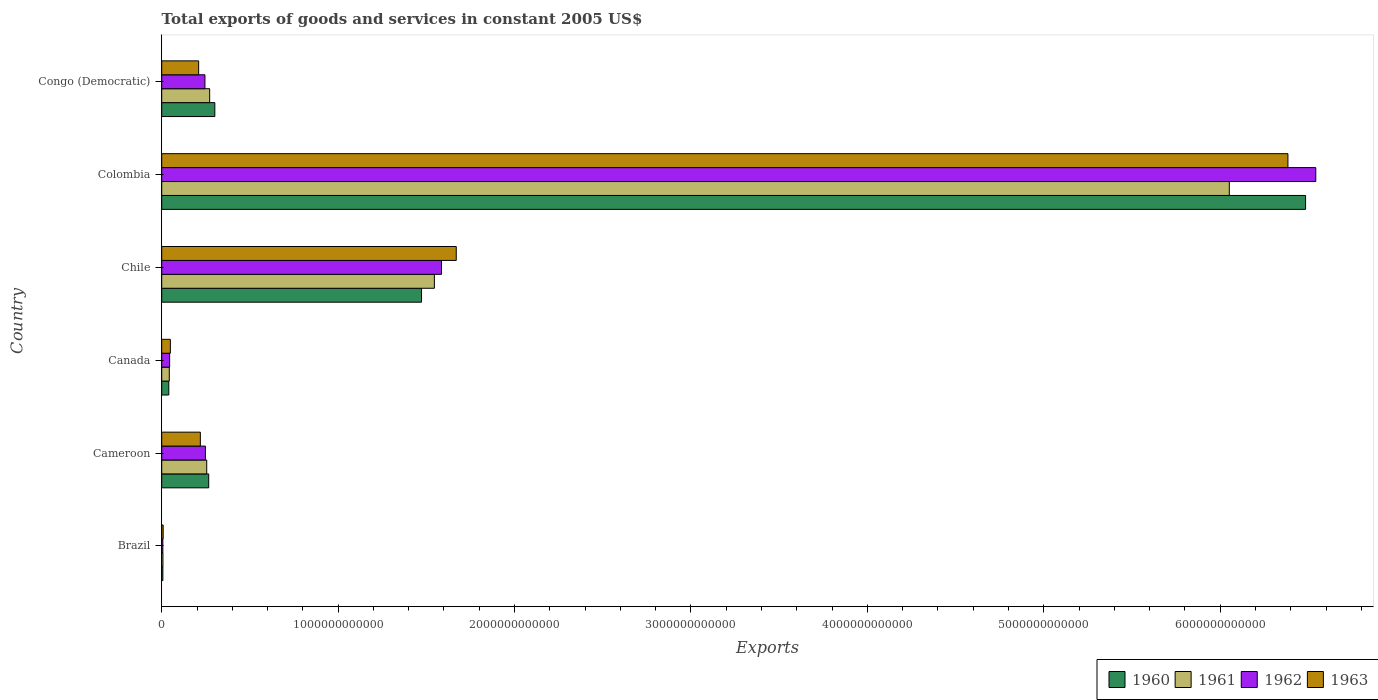How many different coloured bars are there?
Ensure brevity in your answer.  4. Are the number of bars per tick equal to the number of legend labels?
Make the answer very short. Yes. How many bars are there on the 5th tick from the top?
Offer a terse response. 4. What is the total exports of goods and services in 1962 in Congo (Democratic)?
Provide a short and direct response. 2.45e+11. Across all countries, what is the maximum total exports of goods and services in 1960?
Your response must be concise. 6.48e+12. Across all countries, what is the minimum total exports of goods and services in 1960?
Provide a short and direct response. 6.63e+09. In which country was the total exports of goods and services in 1963 maximum?
Your response must be concise. Colombia. In which country was the total exports of goods and services in 1961 minimum?
Keep it short and to the point. Brazil. What is the total total exports of goods and services in 1960 in the graph?
Your response must be concise. 8.57e+12. What is the difference between the total exports of goods and services in 1962 in Brazil and that in Colombia?
Make the answer very short. -6.54e+12. What is the difference between the total exports of goods and services in 1960 in Chile and the total exports of goods and services in 1962 in Colombia?
Offer a very short reply. -5.07e+12. What is the average total exports of goods and services in 1960 per country?
Make the answer very short. 1.43e+12. What is the difference between the total exports of goods and services in 1962 and total exports of goods and services in 1961 in Congo (Democratic)?
Offer a terse response. -2.67e+1. What is the ratio of the total exports of goods and services in 1961 in Brazil to that in Canada?
Provide a succinct answer. 0.16. Is the difference between the total exports of goods and services in 1962 in Brazil and Cameroon greater than the difference between the total exports of goods and services in 1961 in Brazil and Cameroon?
Keep it short and to the point. Yes. What is the difference between the highest and the second highest total exports of goods and services in 1962?
Your answer should be very brief. 4.96e+12. What is the difference between the highest and the lowest total exports of goods and services in 1963?
Make the answer very short. 6.38e+12. In how many countries, is the total exports of goods and services in 1961 greater than the average total exports of goods and services in 1961 taken over all countries?
Ensure brevity in your answer.  2. Is it the case that in every country, the sum of the total exports of goods and services in 1960 and total exports of goods and services in 1962 is greater than the sum of total exports of goods and services in 1961 and total exports of goods and services in 1963?
Your answer should be very brief. No. What does the 3rd bar from the bottom in Chile represents?
Make the answer very short. 1962. Is it the case that in every country, the sum of the total exports of goods and services in 1961 and total exports of goods and services in 1962 is greater than the total exports of goods and services in 1960?
Your answer should be compact. Yes. How many bars are there?
Provide a succinct answer. 24. Are all the bars in the graph horizontal?
Your answer should be very brief. Yes. What is the difference between two consecutive major ticks on the X-axis?
Make the answer very short. 1.00e+12. Are the values on the major ticks of X-axis written in scientific E-notation?
Keep it short and to the point. No. Where does the legend appear in the graph?
Give a very brief answer. Bottom right. How are the legend labels stacked?
Offer a very short reply. Horizontal. What is the title of the graph?
Offer a very short reply. Total exports of goods and services in constant 2005 US$. What is the label or title of the X-axis?
Provide a short and direct response. Exports. What is the Exports in 1960 in Brazil?
Your response must be concise. 6.63e+09. What is the Exports of 1961 in Brazil?
Offer a terse response. 6.97e+09. What is the Exports of 1962 in Brazil?
Provide a succinct answer. 6.46e+09. What is the Exports in 1963 in Brazil?
Your response must be concise. 8.26e+09. What is the Exports in 1960 in Cameroon?
Give a very brief answer. 2.66e+11. What is the Exports in 1961 in Cameroon?
Your answer should be very brief. 2.55e+11. What is the Exports in 1962 in Cameroon?
Give a very brief answer. 2.48e+11. What is the Exports in 1963 in Cameroon?
Give a very brief answer. 2.19e+11. What is the Exports in 1960 in Canada?
Ensure brevity in your answer.  4.02e+1. What is the Exports in 1961 in Canada?
Keep it short and to the point. 4.29e+1. What is the Exports in 1962 in Canada?
Your answer should be very brief. 4.49e+1. What is the Exports of 1963 in Canada?
Offer a very short reply. 4.91e+1. What is the Exports of 1960 in Chile?
Make the answer very short. 1.47e+12. What is the Exports in 1961 in Chile?
Your answer should be very brief. 1.55e+12. What is the Exports in 1962 in Chile?
Keep it short and to the point. 1.59e+12. What is the Exports of 1963 in Chile?
Your response must be concise. 1.67e+12. What is the Exports of 1960 in Colombia?
Your answer should be very brief. 6.48e+12. What is the Exports in 1961 in Colombia?
Keep it short and to the point. 6.05e+12. What is the Exports of 1962 in Colombia?
Provide a short and direct response. 6.54e+12. What is the Exports in 1963 in Colombia?
Your response must be concise. 6.38e+12. What is the Exports of 1960 in Congo (Democratic)?
Provide a succinct answer. 3.01e+11. What is the Exports of 1961 in Congo (Democratic)?
Make the answer very short. 2.72e+11. What is the Exports in 1962 in Congo (Democratic)?
Your answer should be compact. 2.45e+11. What is the Exports in 1963 in Congo (Democratic)?
Keep it short and to the point. 2.09e+11. Across all countries, what is the maximum Exports of 1960?
Keep it short and to the point. 6.48e+12. Across all countries, what is the maximum Exports in 1961?
Provide a short and direct response. 6.05e+12. Across all countries, what is the maximum Exports of 1962?
Provide a short and direct response. 6.54e+12. Across all countries, what is the maximum Exports in 1963?
Offer a very short reply. 6.38e+12. Across all countries, what is the minimum Exports of 1960?
Offer a terse response. 6.63e+09. Across all countries, what is the minimum Exports in 1961?
Offer a terse response. 6.97e+09. Across all countries, what is the minimum Exports of 1962?
Provide a short and direct response. 6.46e+09. Across all countries, what is the minimum Exports in 1963?
Provide a short and direct response. 8.26e+09. What is the total Exports in 1960 in the graph?
Provide a short and direct response. 8.57e+12. What is the total Exports of 1961 in the graph?
Provide a succinct answer. 8.17e+12. What is the total Exports in 1962 in the graph?
Give a very brief answer. 8.67e+12. What is the total Exports of 1963 in the graph?
Ensure brevity in your answer.  8.54e+12. What is the difference between the Exports in 1960 in Brazil and that in Cameroon?
Your answer should be very brief. -2.60e+11. What is the difference between the Exports of 1961 in Brazil and that in Cameroon?
Your answer should be very brief. -2.48e+11. What is the difference between the Exports of 1962 in Brazil and that in Cameroon?
Provide a succinct answer. -2.41e+11. What is the difference between the Exports in 1963 in Brazil and that in Cameroon?
Give a very brief answer. -2.11e+11. What is the difference between the Exports in 1960 in Brazil and that in Canada?
Your answer should be very brief. -3.36e+1. What is the difference between the Exports of 1961 in Brazil and that in Canada?
Provide a short and direct response. -3.60e+1. What is the difference between the Exports of 1962 in Brazil and that in Canada?
Keep it short and to the point. -3.85e+1. What is the difference between the Exports in 1963 in Brazil and that in Canada?
Make the answer very short. -4.08e+1. What is the difference between the Exports in 1960 in Brazil and that in Chile?
Your response must be concise. -1.47e+12. What is the difference between the Exports of 1961 in Brazil and that in Chile?
Provide a succinct answer. -1.54e+12. What is the difference between the Exports of 1962 in Brazil and that in Chile?
Your response must be concise. -1.58e+12. What is the difference between the Exports of 1963 in Brazil and that in Chile?
Make the answer very short. -1.66e+12. What is the difference between the Exports of 1960 in Brazil and that in Colombia?
Your answer should be compact. -6.48e+12. What is the difference between the Exports in 1961 in Brazil and that in Colombia?
Offer a terse response. -6.04e+12. What is the difference between the Exports in 1962 in Brazil and that in Colombia?
Provide a succinct answer. -6.54e+12. What is the difference between the Exports of 1963 in Brazil and that in Colombia?
Your answer should be compact. -6.38e+12. What is the difference between the Exports of 1960 in Brazil and that in Congo (Democratic)?
Provide a short and direct response. -2.94e+11. What is the difference between the Exports of 1961 in Brazil and that in Congo (Democratic)?
Provide a short and direct response. -2.65e+11. What is the difference between the Exports in 1962 in Brazil and that in Congo (Democratic)?
Make the answer very short. -2.39e+11. What is the difference between the Exports of 1963 in Brazil and that in Congo (Democratic)?
Offer a terse response. -2.01e+11. What is the difference between the Exports in 1960 in Cameroon and that in Canada?
Keep it short and to the point. 2.26e+11. What is the difference between the Exports of 1961 in Cameroon and that in Canada?
Your answer should be very brief. 2.12e+11. What is the difference between the Exports of 1962 in Cameroon and that in Canada?
Your answer should be very brief. 2.03e+11. What is the difference between the Exports of 1963 in Cameroon and that in Canada?
Offer a terse response. 1.70e+11. What is the difference between the Exports in 1960 in Cameroon and that in Chile?
Ensure brevity in your answer.  -1.21e+12. What is the difference between the Exports of 1961 in Cameroon and that in Chile?
Offer a terse response. -1.29e+12. What is the difference between the Exports in 1962 in Cameroon and that in Chile?
Provide a succinct answer. -1.34e+12. What is the difference between the Exports of 1963 in Cameroon and that in Chile?
Offer a very short reply. -1.45e+12. What is the difference between the Exports of 1960 in Cameroon and that in Colombia?
Ensure brevity in your answer.  -6.22e+12. What is the difference between the Exports in 1961 in Cameroon and that in Colombia?
Offer a very short reply. -5.80e+12. What is the difference between the Exports of 1962 in Cameroon and that in Colombia?
Offer a very short reply. -6.29e+12. What is the difference between the Exports of 1963 in Cameroon and that in Colombia?
Offer a very short reply. -6.17e+12. What is the difference between the Exports in 1960 in Cameroon and that in Congo (Democratic)?
Your answer should be very brief. -3.46e+1. What is the difference between the Exports of 1961 in Cameroon and that in Congo (Democratic)?
Make the answer very short. -1.66e+1. What is the difference between the Exports of 1962 in Cameroon and that in Congo (Democratic)?
Your answer should be compact. 2.67e+09. What is the difference between the Exports of 1963 in Cameroon and that in Congo (Democratic)?
Your answer should be very brief. 9.56e+09. What is the difference between the Exports in 1960 in Canada and that in Chile?
Keep it short and to the point. -1.43e+12. What is the difference between the Exports of 1961 in Canada and that in Chile?
Offer a very short reply. -1.50e+12. What is the difference between the Exports in 1962 in Canada and that in Chile?
Keep it short and to the point. -1.54e+12. What is the difference between the Exports of 1963 in Canada and that in Chile?
Your answer should be very brief. -1.62e+12. What is the difference between the Exports of 1960 in Canada and that in Colombia?
Your answer should be very brief. -6.44e+12. What is the difference between the Exports in 1961 in Canada and that in Colombia?
Your answer should be very brief. -6.01e+12. What is the difference between the Exports of 1962 in Canada and that in Colombia?
Give a very brief answer. -6.50e+12. What is the difference between the Exports of 1963 in Canada and that in Colombia?
Provide a succinct answer. -6.34e+12. What is the difference between the Exports of 1960 in Canada and that in Congo (Democratic)?
Ensure brevity in your answer.  -2.61e+11. What is the difference between the Exports of 1961 in Canada and that in Congo (Democratic)?
Make the answer very short. -2.29e+11. What is the difference between the Exports of 1962 in Canada and that in Congo (Democratic)?
Keep it short and to the point. -2.00e+11. What is the difference between the Exports of 1963 in Canada and that in Congo (Democratic)?
Provide a succinct answer. -1.60e+11. What is the difference between the Exports of 1960 in Chile and that in Colombia?
Your response must be concise. -5.01e+12. What is the difference between the Exports of 1961 in Chile and that in Colombia?
Give a very brief answer. -4.51e+12. What is the difference between the Exports of 1962 in Chile and that in Colombia?
Give a very brief answer. -4.96e+12. What is the difference between the Exports in 1963 in Chile and that in Colombia?
Provide a short and direct response. -4.71e+12. What is the difference between the Exports in 1960 in Chile and that in Congo (Democratic)?
Offer a terse response. 1.17e+12. What is the difference between the Exports in 1961 in Chile and that in Congo (Democratic)?
Give a very brief answer. 1.27e+12. What is the difference between the Exports in 1962 in Chile and that in Congo (Democratic)?
Give a very brief answer. 1.34e+12. What is the difference between the Exports of 1963 in Chile and that in Congo (Democratic)?
Provide a short and direct response. 1.46e+12. What is the difference between the Exports in 1960 in Colombia and that in Congo (Democratic)?
Your answer should be compact. 6.18e+12. What is the difference between the Exports in 1961 in Colombia and that in Congo (Democratic)?
Give a very brief answer. 5.78e+12. What is the difference between the Exports of 1962 in Colombia and that in Congo (Democratic)?
Your answer should be compact. 6.30e+12. What is the difference between the Exports in 1963 in Colombia and that in Congo (Democratic)?
Ensure brevity in your answer.  6.17e+12. What is the difference between the Exports in 1960 in Brazil and the Exports in 1961 in Cameroon?
Offer a terse response. -2.48e+11. What is the difference between the Exports in 1960 in Brazil and the Exports in 1962 in Cameroon?
Provide a succinct answer. -2.41e+11. What is the difference between the Exports in 1960 in Brazil and the Exports in 1963 in Cameroon?
Offer a terse response. -2.12e+11. What is the difference between the Exports in 1961 in Brazil and the Exports in 1962 in Cameroon?
Your answer should be very brief. -2.41e+11. What is the difference between the Exports in 1961 in Brazil and the Exports in 1963 in Cameroon?
Your answer should be very brief. -2.12e+11. What is the difference between the Exports of 1962 in Brazil and the Exports of 1963 in Cameroon?
Keep it short and to the point. -2.13e+11. What is the difference between the Exports in 1960 in Brazil and the Exports in 1961 in Canada?
Keep it short and to the point. -3.63e+1. What is the difference between the Exports in 1960 in Brazil and the Exports in 1962 in Canada?
Provide a short and direct response. -3.83e+1. What is the difference between the Exports in 1960 in Brazil and the Exports in 1963 in Canada?
Make the answer very short. -4.24e+1. What is the difference between the Exports of 1961 in Brazil and the Exports of 1962 in Canada?
Offer a terse response. -3.79e+1. What is the difference between the Exports in 1961 in Brazil and the Exports in 1963 in Canada?
Provide a short and direct response. -4.21e+1. What is the difference between the Exports of 1962 in Brazil and the Exports of 1963 in Canada?
Ensure brevity in your answer.  -4.26e+1. What is the difference between the Exports of 1960 in Brazil and the Exports of 1961 in Chile?
Ensure brevity in your answer.  -1.54e+12. What is the difference between the Exports in 1960 in Brazil and the Exports in 1962 in Chile?
Provide a succinct answer. -1.58e+12. What is the difference between the Exports of 1960 in Brazil and the Exports of 1963 in Chile?
Your response must be concise. -1.66e+12. What is the difference between the Exports in 1961 in Brazil and the Exports in 1962 in Chile?
Keep it short and to the point. -1.58e+12. What is the difference between the Exports of 1961 in Brazil and the Exports of 1963 in Chile?
Provide a short and direct response. -1.66e+12. What is the difference between the Exports in 1962 in Brazil and the Exports in 1963 in Chile?
Provide a succinct answer. -1.66e+12. What is the difference between the Exports in 1960 in Brazil and the Exports in 1961 in Colombia?
Ensure brevity in your answer.  -6.05e+12. What is the difference between the Exports in 1960 in Brazil and the Exports in 1962 in Colombia?
Offer a terse response. -6.54e+12. What is the difference between the Exports in 1960 in Brazil and the Exports in 1963 in Colombia?
Offer a very short reply. -6.38e+12. What is the difference between the Exports in 1961 in Brazil and the Exports in 1962 in Colombia?
Ensure brevity in your answer.  -6.54e+12. What is the difference between the Exports in 1961 in Brazil and the Exports in 1963 in Colombia?
Ensure brevity in your answer.  -6.38e+12. What is the difference between the Exports in 1962 in Brazil and the Exports in 1963 in Colombia?
Make the answer very short. -6.38e+12. What is the difference between the Exports in 1960 in Brazil and the Exports in 1961 in Congo (Democratic)?
Give a very brief answer. -2.65e+11. What is the difference between the Exports in 1960 in Brazil and the Exports in 1962 in Congo (Democratic)?
Your answer should be very brief. -2.38e+11. What is the difference between the Exports of 1960 in Brazil and the Exports of 1963 in Congo (Democratic)?
Provide a short and direct response. -2.03e+11. What is the difference between the Exports in 1961 in Brazil and the Exports in 1962 in Congo (Democratic)?
Make the answer very short. -2.38e+11. What is the difference between the Exports in 1961 in Brazil and the Exports in 1963 in Congo (Democratic)?
Your response must be concise. -2.02e+11. What is the difference between the Exports of 1962 in Brazil and the Exports of 1963 in Congo (Democratic)?
Your answer should be very brief. -2.03e+11. What is the difference between the Exports of 1960 in Cameroon and the Exports of 1961 in Canada?
Keep it short and to the point. 2.24e+11. What is the difference between the Exports in 1960 in Cameroon and the Exports in 1962 in Canada?
Offer a very short reply. 2.22e+11. What is the difference between the Exports of 1960 in Cameroon and the Exports of 1963 in Canada?
Offer a terse response. 2.17e+11. What is the difference between the Exports of 1961 in Cameroon and the Exports of 1962 in Canada?
Ensure brevity in your answer.  2.10e+11. What is the difference between the Exports in 1961 in Cameroon and the Exports in 1963 in Canada?
Provide a succinct answer. 2.06e+11. What is the difference between the Exports in 1962 in Cameroon and the Exports in 1963 in Canada?
Give a very brief answer. 1.99e+11. What is the difference between the Exports of 1960 in Cameroon and the Exports of 1961 in Chile?
Ensure brevity in your answer.  -1.28e+12. What is the difference between the Exports of 1960 in Cameroon and the Exports of 1962 in Chile?
Give a very brief answer. -1.32e+12. What is the difference between the Exports of 1960 in Cameroon and the Exports of 1963 in Chile?
Ensure brevity in your answer.  -1.40e+12. What is the difference between the Exports of 1961 in Cameroon and the Exports of 1962 in Chile?
Offer a very short reply. -1.33e+12. What is the difference between the Exports in 1961 in Cameroon and the Exports in 1963 in Chile?
Make the answer very short. -1.41e+12. What is the difference between the Exports in 1962 in Cameroon and the Exports in 1963 in Chile?
Make the answer very short. -1.42e+12. What is the difference between the Exports in 1960 in Cameroon and the Exports in 1961 in Colombia?
Your answer should be very brief. -5.79e+12. What is the difference between the Exports of 1960 in Cameroon and the Exports of 1962 in Colombia?
Provide a succinct answer. -6.28e+12. What is the difference between the Exports of 1960 in Cameroon and the Exports of 1963 in Colombia?
Your answer should be compact. -6.12e+12. What is the difference between the Exports of 1961 in Cameroon and the Exports of 1962 in Colombia?
Ensure brevity in your answer.  -6.29e+12. What is the difference between the Exports of 1961 in Cameroon and the Exports of 1963 in Colombia?
Your answer should be very brief. -6.13e+12. What is the difference between the Exports of 1962 in Cameroon and the Exports of 1963 in Colombia?
Your response must be concise. -6.14e+12. What is the difference between the Exports in 1960 in Cameroon and the Exports in 1961 in Congo (Democratic)?
Your answer should be compact. -5.27e+09. What is the difference between the Exports of 1960 in Cameroon and the Exports of 1962 in Congo (Democratic)?
Keep it short and to the point. 2.15e+1. What is the difference between the Exports in 1960 in Cameroon and the Exports in 1963 in Congo (Democratic)?
Give a very brief answer. 5.70e+1. What is the difference between the Exports of 1961 in Cameroon and the Exports of 1962 in Congo (Democratic)?
Your answer should be compact. 1.01e+1. What is the difference between the Exports in 1961 in Cameroon and the Exports in 1963 in Congo (Democratic)?
Make the answer very short. 4.57e+1. What is the difference between the Exports of 1962 in Cameroon and the Exports of 1963 in Congo (Democratic)?
Offer a terse response. 3.83e+1. What is the difference between the Exports in 1960 in Canada and the Exports in 1961 in Chile?
Your response must be concise. -1.51e+12. What is the difference between the Exports of 1960 in Canada and the Exports of 1962 in Chile?
Offer a terse response. -1.55e+12. What is the difference between the Exports in 1960 in Canada and the Exports in 1963 in Chile?
Your response must be concise. -1.63e+12. What is the difference between the Exports of 1961 in Canada and the Exports of 1962 in Chile?
Ensure brevity in your answer.  -1.54e+12. What is the difference between the Exports of 1961 in Canada and the Exports of 1963 in Chile?
Provide a short and direct response. -1.63e+12. What is the difference between the Exports of 1962 in Canada and the Exports of 1963 in Chile?
Your answer should be very brief. -1.62e+12. What is the difference between the Exports in 1960 in Canada and the Exports in 1961 in Colombia?
Offer a terse response. -6.01e+12. What is the difference between the Exports of 1960 in Canada and the Exports of 1962 in Colombia?
Give a very brief answer. -6.50e+12. What is the difference between the Exports in 1960 in Canada and the Exports in 1963 in Colombia?
Offer a terse response. -6.34e+12. What is the difference between the Exports in 1961 in Canada and the Exports in 1962 in Colombia?
Keep it short and to the point. -6.50e+12. What is the difference between the Exports in 1961 in Canada and the Exports in 1963 in Colombia?
Offer a terse response. -6.34e+12. What is the difference between the Exports in 1962 in Canada and the Exports in 1963 in Colombia?
Offer a terse response. -6.34e+12. What is the difference between the Exports of 1960 in Canada and the Exports of 1961 in Congo (Democratic)?
Provide a succinct answer. -2.32e+11. What is the difference between the Exports in 1960 in Canada and the Exports in 1962 in Congo (Democratic)?
Offer a terse response. -2.05e+11. What is the difference between the Exports of 1960 in Canada and the Exports of 1963 in Congo (Democratic)?
Keep it short and to the point. -1.69e+11. What is the difference between the Exports in 1961 in Canada and the Exports in 1962 in Congo (Democratic)?
Make the answer very short. -2.02e+11. What is the difference between the Exports in 1961 in Canada and the Exports in 1963 in Congo (Democratic)?
Your response must be concise. -1.67e+11. What is the difference between the Exports in 1962 in Canada and the Exports in 1963 in Congo (Democratic)?
Make the answer very short. -1.65e+11. What is the difference between the Exports of 1960 in Chile and the Exports of 1961 in Colombia?
Provide a succinct answer. -4.58e+12. What is the difference between the Exports in 1960 in Chile and the Exports in 1962 in Colombia?
Keep it short and to the point. -5.07e+12. What is the difference between the Exports of 1960 in Chile and the Exports of 1963 in Colombia?
Your response must be concise. -4.91e+12. What is the difference between the Exports in 1961 in Chile and the Exports in 1962 in Colombia?
Your answer should be very brief. -5.00e+12. What is the difference between the Exports of 1961 in Chile and the Exports of 1963 in Colombia?
Ensure brevity in your answer.  -4.84e+12. What is the difference between the Exports of 1962 in Chile and the Exports of 1963 in Colombia?
Offer a very short reply. -4.80e+12. What is the difference between the Exports in 1960 in Chile and the Exports in 1961 in Congo (Democratic)?
Ensure brevity in your answer.  1.20e+12. What is the difference between the Exports in 1960 in Chile and the Exports in 1962 in Congo (Democratic)?
Your answer should be very brief. 1.23e+12. What is the difference between the Exports in 1960 in Chile and the Exports in 1963 in Congo (Democratic)?
Your answer should be compact. 1.26e+12. What is the difference between the Exports of 1961 in Chile and the Exports of 1962 in Congo (Democratic)?
Give a very brief answer. 1.30e+12. What is the difference between the Exports of 1961 in Chile and the Exports of 1963 in Congo (Democratic)?
Make the answer very short. 1.34e+12. What is the difference between the Exports of 1962 in Chile and the Exports of 1963 in Congo (Democratic)?
Provide a succinct answer. 1.38e+12. What is the difference between the Exports of 1960 in Colombia and the Exports of 1961 in Congo (Democratic)?
Your answer should be very brief. 6.21e+12. What is the difference between the Exports in 1960 in Colombia and the Exports in 1962 in Congo (Democratic)?
Keep it short and to the point. 6.24e+12. What is the difference between the Exports of 1960 in Colombia and the Exports of 1963 in Congo (Democratic)?
Offer a very short reply. 6.27e+12. What is the difference between the Exports in 1961 in Colombia and the Exports in 1962 in Congo (Democratic)?
Make the answer very short. 5.81e+12. What is the difference between the Exports of 1961 in Colombia and the Exports of 1963 in Congo (Democratic)?
Your response must be concise. 5.84e+12. What is the difference between the Exports in 1962 in Colombia and the Exports in 1963 in Congo (Democratic)?
Keep it short and to the point. 6.33e+12. What is the average Exports of 1960 per country?
Keep it short and to the point. 1.43e+12. What is the average Exports of 1961 per country?
Ensure brevity in your answer.  1.36e+12. What is the average Exports of 1962 per country?
Give a very brief answer. 1.45e+12. What is the average Exports in 1963 per country?
Offer a terse response. 1.42e+12. What is the difference between the Exports of 1960 and Exports of 1961 in Brazil?
Your answer should be very brief. -3.44e+08. What is the difference between the Exports of 1960 and Exports of 1962 in Brazil?
Offer a very short reply. 1.72e+08. What is the difference between the Exports in 1960 and Exports in 1963 in Brazil?
Your response must be concise. -1.64e+09. What is the difference between the Exports in 1961 and Exports in 1962 in Brazil?
Your answer should be compact. 5.16e+08. What is the difference between the Exports of 1961 and Exports of 1963 in Brazil?
Provide a succinct answer. -1.29e+09. What is the difference between the Exports in 1962 and Exports in 1963 in Brazil?
Give a very brief answer. -1.81e+09. What is the difference between the Exports in 1960 and Exports in 1961 in Cameroon?
Your answer should be compact. 1.14e+1. What is the difference between the Exports of 1960 and Exports of 1962 in Cameroon?
Offer a very short reply. 1.88e+1. What is the difference between the Exports of 1960 and Exports of 1963 in Cameroon?
Make the answer very short. 4.75e+1. What is the difference between the Exports of 1961 and Exports of 1962 in Cameroon?
Provide a short and direct response. 7.43e+09. What is the difference between the Exports in 1961 and Exports in 1963 in Cameroon?
Your response must be concise. 3.61e+1. What is the difference between the Exports of 1962 and Exports of 1963 in Cameroon?
Keep it short and to the point. 2.87e+1. What is the difference between the Exports of 1960 and Exports of 1961 in Canada?
Ensure brevity in your answer.  -2.73e+09. What is the difference between the Exports of 1960 and Exports of 1962 in Canada?
Give a very brief answer. -4.72e+09. What is the difference between the Exports in 1960 and Exports in 1963 in Canada?
Your response must be concise. -8.86e+09. What is the difference between the Exports of 1961 and Exports of 1962 in Canada?
Your answer should be very brief. -1.98e+09. What is the difference between the Exports in 1961 and Exports in 1963 in Canada?
Offer a terse response. -6.12e+09. What is the difference between the Exports of 1962 and Exports of 1963 in Canada?
Your response must be concise. -4.14e+09. What is the difference between the Exports of 1960 and Exports of 1961 in Chile?
Your response must be concise. -7.28e+1. What is the difference between the Exports of 1960 and Exports of 1962 in Chile?
Offer a very short reply. -1.13e+11. What is the difference between the Exports in 1960 and Exports in 1963 in Chile?
Provide a succinct answer. -1.97e+11. What is the difference between the Exports of 1961 and Exports of 1962 in Chile?
Provide a short and direct response. -4.03e+1. What is the difference between the Exports in 1961 and Exports in 1963 in Chile?
Ensure brevity in your answer.  -1.24e+11. What is the difference between the Exports in 1962 and Exports in 1963 in Chile?
Your response must be concise. -8.37e+1. What is the difference between the Exports of 1960 and Exports of 1961 in Colombia?
Give a very brief answer. 4.32e+11. What is the difference between the Exports in 1960 and Exports in 1962 in Colombia?
Provide a succinct answer. -5.79e+1. What is the difference between the Exports of 1960 and Exports of 1963 in Colombia?
Give a very brief answer. 1.00e+11. What is the difference between the Exports in 1961 and Exports in 1962 in Colombia?
Give a very brief answer. -4.90e+11. What is the difference between the Exports of 1961 and Exports of 1963 in Colombia?
Offer a terse response. -3.32e+11. What is the difference between the Exports of 1962 and Exports of 1963 in Colombia?
Keep it short and to the point. 1.58e+11. What is the difference between the Exports in 1960 and Exports in 1961 in Congo (Democratic)?
Your answer should be very brief. 2.94e+1. What is the difference between the Exports in 1960 and Exports in 1962 in Congo (Democratic)?
Provide a succinct answer. 5.61e+1. What is the difference between the Exports in 1960 and Exports in 1963 in Congo (Democratic)?
Make the answer very short. 9.17e+1. What is the difference between the Exports of 1961 and Exports of 1962 in Congo (Democratic)?
Your answer should be very brief. 2.67e+1. What is the difference between the Exports in 1961 and Exports in 1963 in Congo (Democratic)?
Your answer should be compact. 6.23e+1. What is the difference between the Exports of 1962 and Exports of 1963 in Congo (Democratic)?
Your response must be concise. 3.56e+1. What is the ratio of the Exports of 1960 in Brazil to that in Cameroon?
Give a very brief answer. 0.02. What is the ratio of the Exports in 1961 in Brazil to that in Cameroon?
Offer a very short reply. 0.03. What is the ratio of the Exports in 1962 in Brazil to that in Cameroon?
Offer a terse response. 0.03. What is the ratio of the Exports in 1963 in Brazil to that in Cameroon?
Ensure brevity in your answer.  0.04. What is the ratio of the Exports in 1960 in Brazil to that in Canada?
Your response must be concise. 0.16. What is the ratio of the Exports in 1961 in Brazil to that in Canada?
Your answer should be compact. 0.16. What is the ratio of the Exports in 1962 in Brazil to that in Canada?
Offer a very short reply. 0.14. What is the ratio of the Exports in 1963 in Brazil to that in Canada?
Your response must be concise. 0.17. What is the ratio of the Exports of 1960 in Brazil to that in Chile?
Keep it short and to the point. 0. What is the ratio of the Exports of 1961 in Brazil to that in Chile?
Provide a short and direct response. 0. What is the ratio of the Exports of 1962 in Brazil to that in Chile?
Keep it short and to the point. 0. What is the ratio of the Exports of 1963 in Brazil to that in Chile?
Provide a succinct answer. 0. What is the ratio of the Exports in 1960 in Brazil to that in Colombia?
Make the answer very short. 0. What is the ratio of the Exports of 1961 in Brazil to that in Colombia?
Offer a very short reply. 0. What is the ratio of the Exports in 1963 in Brazil to that in Colombia?
Offer a very short reply. 0. What is the ratio of the Exports of 1960 in Brazil to that in Congo (Democratic)?
Provide a succinct answer. 0.02. What is the ratio of the Exports in 1961 in Brazil to that in Congo (Democratic)?
Offer a very short reply. 0.03. What is the ratio of the Exports of 1962 in Brazil to that in Congo (Democratic)?
Provide a succinct answer. 0.03. What is the ratio of the Exports in 1963 in Brazil to that in Congo (Democratic)?
Make the answer very short. 0.04. What is the ratio of the Exports in 1960 in Cameroon to that in Canada?
Ensure brevity in your answer.  6.63. What is the ratio of the Exports in 1961 in Cameroon to that in Canada?
Provide a succinct answer. 5.94. What is the ratio of the Exports of 1962 in Cameroon to that in Canada?
Offer a very short reply. 5.51. What is the ratio of the Exports in 1963 in Cameroon to that in Canada?
Your answer should be very brief. 4.46. What is the ratio of the Exports of 1960 in Cameroon to that in Chile?
Offer a very short reply. 0.18. What is the ratio of the Exports of 1961 in Cameroon to that in Chile?
Provide a succinct answer. 0.17. What is the ratio of the Exports in 1962 in Cameroon to that in Chile?
Keep it short and to the point. 0.16. What is the ratio of the Exports of 1963 in Cameroon to that in Chile?
Your answer should be very brief. 0.13. What is the ratio of the Exports in 1960 in Cameroon to that in Colombia?
Make the answer very short. 0.04. What is the ratio of the Exports in 1961 in Cameroon to that in Colombia?
Give a very brief answer. 0.04. What is the ratio of the Exports in 1962 in Cameroon to that in Colombia?
Provide a succinct answer. 0.04. What is the ratio of the Exports in 1963 in Cameroon to that in Colombia?
Offer a terse response. 0.03. What is the ratio of the Exports of 1960 in Cameroon to that in Congo (Democratic)?
Keep it short and to the point. 0.88. What is the ratio of the Exports in 1961 in Cameroon to that in Congo (Democratic)?
Keep it short and to the point. 0.94. What is the ratio of the Exports of 1962 in Cameroon to that in Congo (Democratic)?
Provide a succinct answer. 1.01. What is the ratio of the Exports of 1963 in Cameroon to that in Congo (Democratic)?
Make the answer very short. 1.05. What is the ratio of the Exports of 1960 in Canada to that in Chile?
Ensure brevity in your answer.  0.03. What is the ratio of the Exports in 1961 in Canada to that in Chile?
Keep it short and to the point. 0.03. What is the ratio of the Exports in 1962 in Canada to that in Chile?
Your answer should be very brief. 0.03. What is the ratio of the Exports of 1963 in Canada to that in Chile?
Your response must be concise. 0.03. What is the ratio of the Exports of 1960 in Canada to that in Colombia?
Your answer should be compact. 0.01. What is the ratio of the Exports in 1961 in Canada to that in Colombia?
Provide a short and direct response. 0.01. What is the ratio of the Exports in 1962 in Canada to that in Colombia?
Provide a succinct answer. 0.01. What is the ratio of the Exports in 1963 in Canada to that in Colombia?
Make the answer very short. 0.01. What is the ratio of the Exports in 1960 in Canada to that in Congo (Democratic)?
Offer a terse response. 0.13. What is the ratio of the Exports in 1961 in Canada to that in Congo (Democratic)?
Your answer should be compact. 0.16. What is the ratio of the Exports of 1962 in Canada to that in Congo (Democratic)?
Your answer should be very brief. 0.18. What is the ratio of the Exports in 1963 in Canada to that in Congo (Democratic)?
Keep it short and to the point. 0.23. What is the ratio of the Exports of 1960 in Chile to that in Colombia?
Your answer should be compact. 0.23. What is the ratio of the Exports of 1961 in Chile to that in Colombia?
Keep it short and to the point. 0.26. What is the ratio of the Exports of 1962 in Chile to that in Colombia?
Ensure brevity in your answer.  0.24. What is the ratio of the Exports of 1963 in Chile to that in Colombia?
Your response must be concise. 0.26. What is the ratio of the Exports in 1960 in Chile to that in Congo (Democratic)?
Keep it short and to the point. 4.89. What is the ratio of the Exports in 1961 in Chile to that in Congo (Democratic)?
Your response must be concise. 5.69. What is the ratio of the Exports in 1962 in Chile to that in Congo (Democratic)?
Give a very brief answer. 6.47. What is the ratio of the Exports in 1963 in Chile to that in Congo (Democratic)?
Offer a very short reply. 7.97. What is the ratio of the Exports of 1960 in Colombia to that in Congo (Democratic)?
Your response must be concise. 21.53. What is the ratio of the Exports of 1961 in Colombia to that in Congo (Democratic)?
Ensure brevity in your answer.  22.27. What is the ratio of the Exports in 1962 in Colombia to that in Congo (Democratic)?
Keep it short and to the point. 26.7. What is the ratio of the Exports in 1963 in Colombia to that in Congo (Democratic)?
Provide a succinct answer. 30.48. What is the difference between the highest and the second highest Exports of 1960?
Provide a short and direct response. 5.01e+12. What is the difference between the highest and the second highest Exports of 1961?
Keep it short and to the point. 4.51e+12. What is the difference between the highest and the second highest Exports in 1962?
Provide a succinct answer. 4.96e+12. What is the difference between the highest and the second highest Exports in 1963?
Offer a terse response. 4.71e+12. What is the difference between the highest and the lowest Exports in 1960?
Offer a terse response. 6.48e+12. What is the difference between the highest and the lowest Exports of 1961?
Make the answer very short. 6.04e+12. What is the difference between the highest and the lowest Exports of 1962?
Your answer should be very brief. 6.54e+12. What is the difference between the highest and the lowest Exports in 1963?
Make the answer very short. 6.38e+12. 